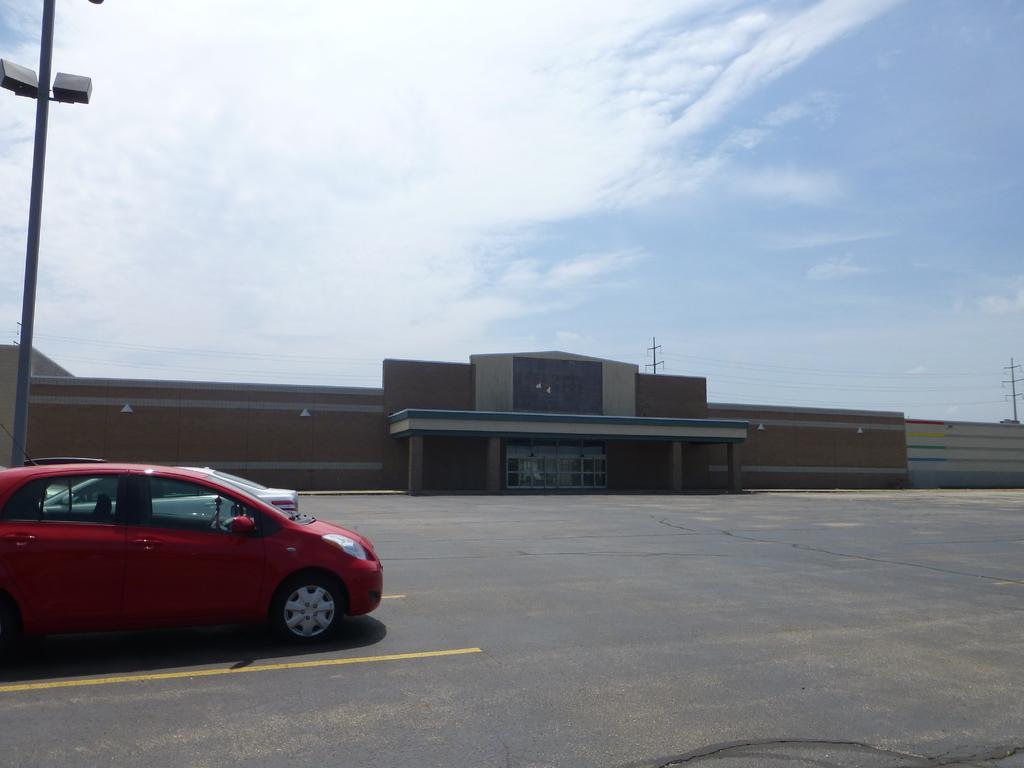In one or two sentences, can you explain what this image depicts? In this image I can see the sky and I can see the wall and the building and I can see a red color vehicle parking on the road and I can see pole visible on the right side. 